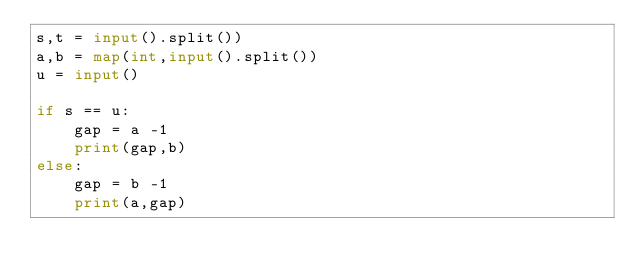Convert code to text. <code><loc_0><loc_0><loc_500><loc_500><_Python_>s,t = input().split())
a,b = map(int,input().split())
u = input()

if s == u:
    gap = a -1
    print(gap,b)
else:
    gap = b -1
    print(a,gap)</code> 